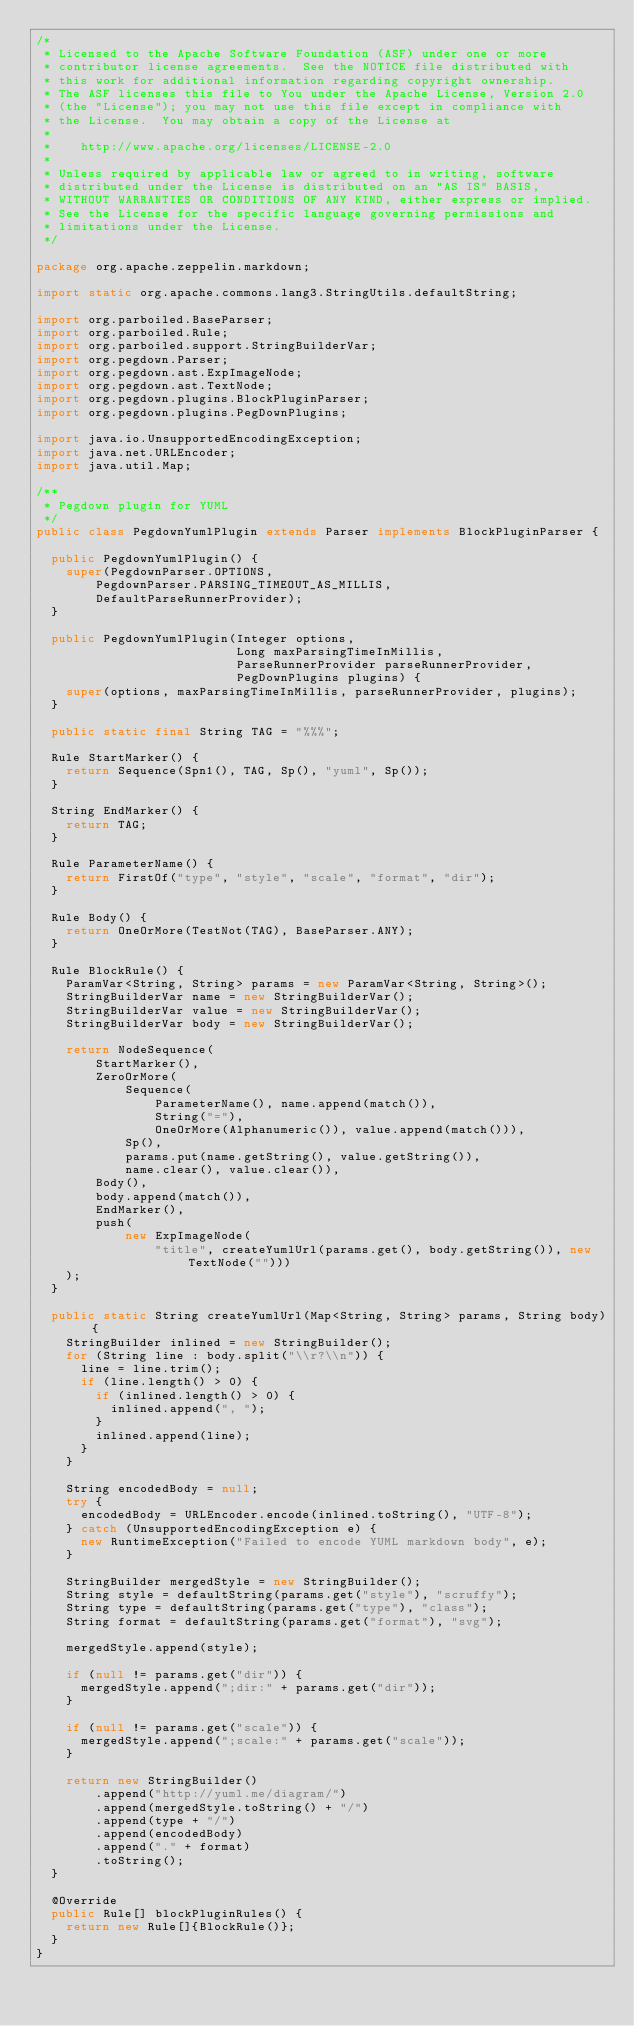Convert code to text. <code><loc_0><loc_0><loc_500><loc_500><_Java_>/*
 * Licensed to the Apache Software Foundation (ASF) under one or more
 * contributor license agreements.  See the NOTICE file distributed with
 * this work for additional information regarding copyright ownership.
 * The ASF licenses this file to You under the Apache License, Version 2.0
 * (the "License"); you may not use this file except in compliance with
 * the License.  You may obtain a copy of the License at
 *
 *    http://www.apache.org/licenses/LICENSE-2.0
 *
 * Unless required by applicable law or agreed to in writing, software
 * distributed under the License is distributed on an "AS IS" BASIS,
 * WITHOUT WARRANTIES OR CONDITIONS OF ANY KIND, either express or implied.
 * See the License for the specific language governing permissions and
 * limitations under the License.
 */

package org.apache.zeppelin.markdown;

import static org.apache.commons.lang3.StringUtils.defaultString;

import org.parboiled.BaseParser;
import org.parboiled.Rule;
import org.parboiled.support.StringBuilderVar;
import org.pegdown.Parser;
import org.pegdown.ast.ExpImageNode;
import org.pegdown.ast.TextNode;
import org.pegdown.plugins.BlockPluginParser;
import org.pegdown.plugins.PegDownPlugins;

import java.io.UnsupportedEncodingException;
import java.net.URLEncoder;
import java.util.Map;

/**
 * Pegdown plugin for YUML
 */
public class PegdownYumlPlugin extends Parser implements BlockPluginParser {

  public PegdownYumlPlugin() {
    super(PegdownParser.OPTIONS,
        PegdownParser.PARSING_TIMEOUT_AS_MILLIS,
        DefaultParseRunnerProvider);
  }

  public PegdownYumlPlugin(Integer options,
                           Long maxParsingTimeInMillis,
                           ParseRunnerProvider parseRunnerProvider,
                           PegDownPlugins plugins) {
    super(options, maxParsingTimeInMillis, parseRunnerProvider, plugins);
  }

  public static final String TAG = "%%%";

  Rule StartMarker() {
    return Sequence(Spn1(), TAG, Sp(), "yuml", Sp());
  }

  String EndMarker() {
    return TAG;
  }

  Rule ParameterName() {
    return FirstOf("type", "style", "scale", "format", "dir");
  }

  Rule Body() {
    return OneOrMore(TestNot(TAG), BaseParser.ANY);
  }

  Rule BlockRule() {
    ParamVar<String, String> params = new ParamVar<String, String>();
    StringBuilderVar name = new StringBuilderVar();
    StringBuilderVar value = new StringBuilderVar();
    StringBuilderVar body = new StringBuilderVar();

    return NodeSequence(
        StartMarker(),
        ZeroOrMore(
            Sequence(
                ParameterName(), name.append(match()),
                String("="),
                OneOrMore(Alphanumeric()), value.append(match())),
            Sp(),
            params.put(name.getString(), value.getString()),
            name.clear(), value.clear()),
        Body(),
        body.append(match()),
        EndMarker(),
        push(
            new ExpImageNode(
                "title", createYumlUrl(params.get(), body.getString()), new TextNode("")))
    );
  }

  public static String createYumlUrl(Map<String, String> params, String body) {
    StringBuilder inlined = new StringBuilder();
    for (String line : body.split("\\r?\\n")) {
      line = line.trim();
      if (line.length() > 0) {
        if (inlined.length() > 0) {
          inlined.append(", ");
        }
        inlined.append(line);
      }
    }

    String encodedBody = null;
    try {
      encodedBody = URLEncoder.encode(inlined.toString(), "UTF-8");
    } catch (UnsupportedEncodingException e) {
      new RuntimeException("Failed to encode YUML markdown body", e);
    }

    StringBuilder mergedStyle = new StringBuilder();
    String style = defaultString(params.get("style"), "scruffy");
    String type = defaultString(params.get("type"), "class");
    String format = defaultString(params.get("format"), "svg");

    mergedStyle.append(style);

    if (null != params.get("dir")) {
      mergedStyle.append(";dir:" + params.get("dir"));
    }

    if (null != params.get("scale")) {
      mergedStyle.append(";scale:" + params.get("scale"));
    }

    return new StringBuilder()
        .append("http://yuml.me/diagram/")
        .append(mergedStyle.toString() + "/")
        .append(type + "/")
        .append(encodedBody)
        .append("." + format)
        .toString();
  }

  @Override
  public Rule[] blockPluginRules() {
    return new Rule[]{BlockRule()};
  }
}
</code> 